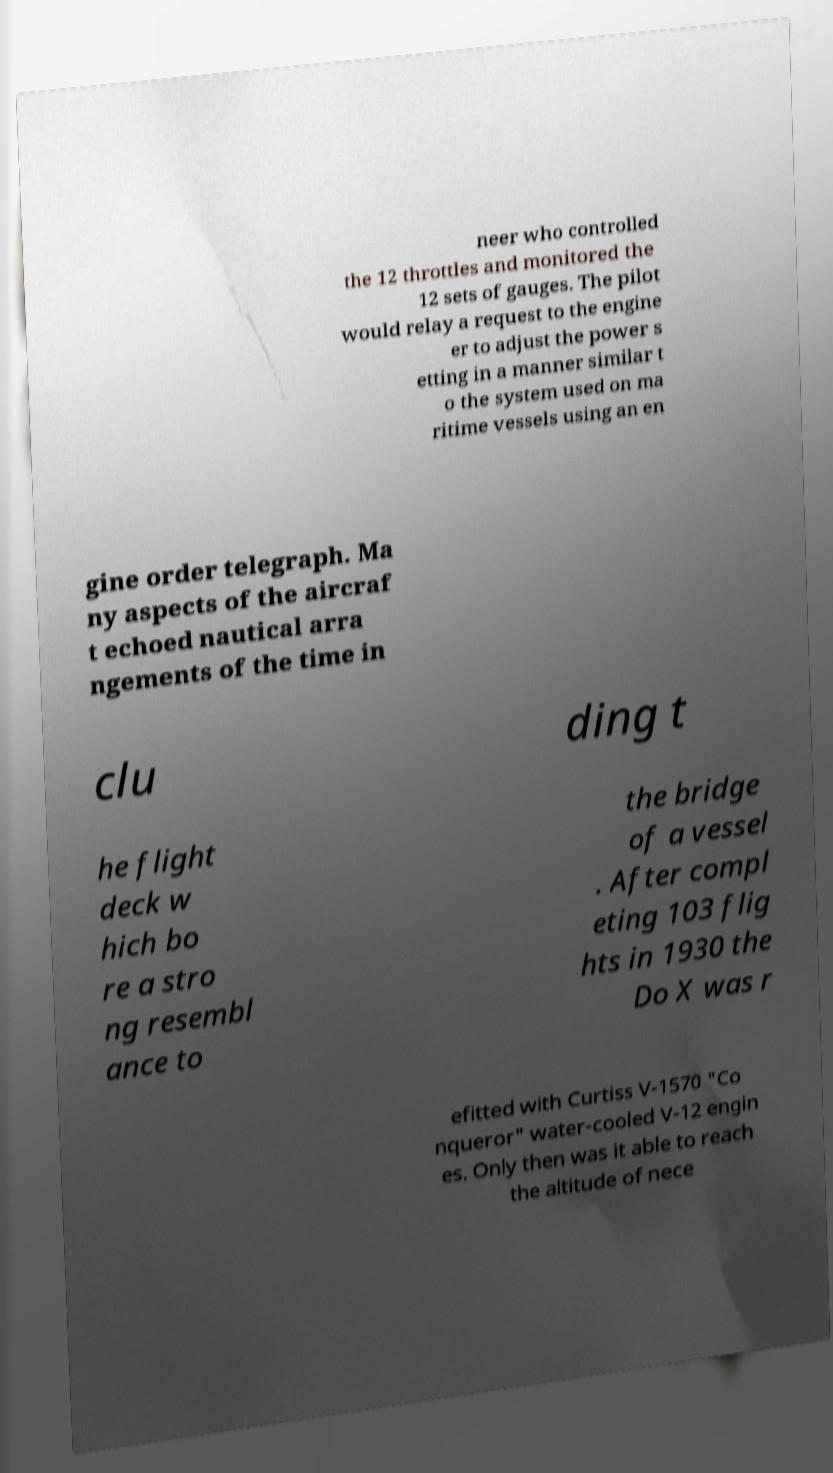Could you extract and type out the text from this image? neer who controlled the 12 throttles and monitored the 12 sets of gauges. The pilot would relay a request to the engine er to adjust the power s etting in a manner similar t o the system used on ma ritime vessels using an en gine order telegraph. Ma ny aspects of the aircraf t echoed nautical arra ngements of the time in clu ding t he flight deck w hich bo re a stro ng resembl ance to the bridge of a vessel . After compl eting 103 flig hts in 1930 the Do X was r efitted with Curtiss V-1570 "Co nqueror" water-cooled V-12 engin es. Only then was it able to reach the altitude of nece 